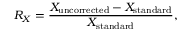Convert formula to latex. <formula><loc_0><loc_0><loc_500><loc_500>R _ { X } = \frac { X _ { u n c o r r e c t e d } - X _ { s t a n d a r d } } { X _ { s t a n d a r d } } ,</formula> 